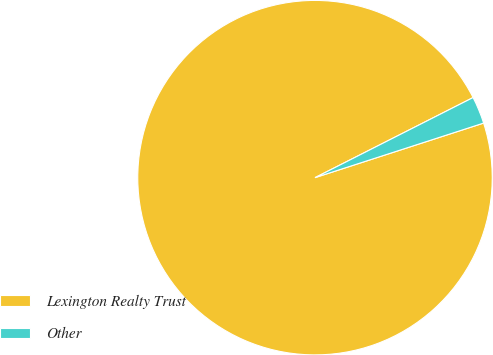Convert chart to OTSL. <chart><loc_0><loc_0><loc_500><loc_500><pie_chart><fcel>Lexington Realty Trust<fcel>Other<nl><fcel>97.52%<fcel>2.48%<nl></chart> 